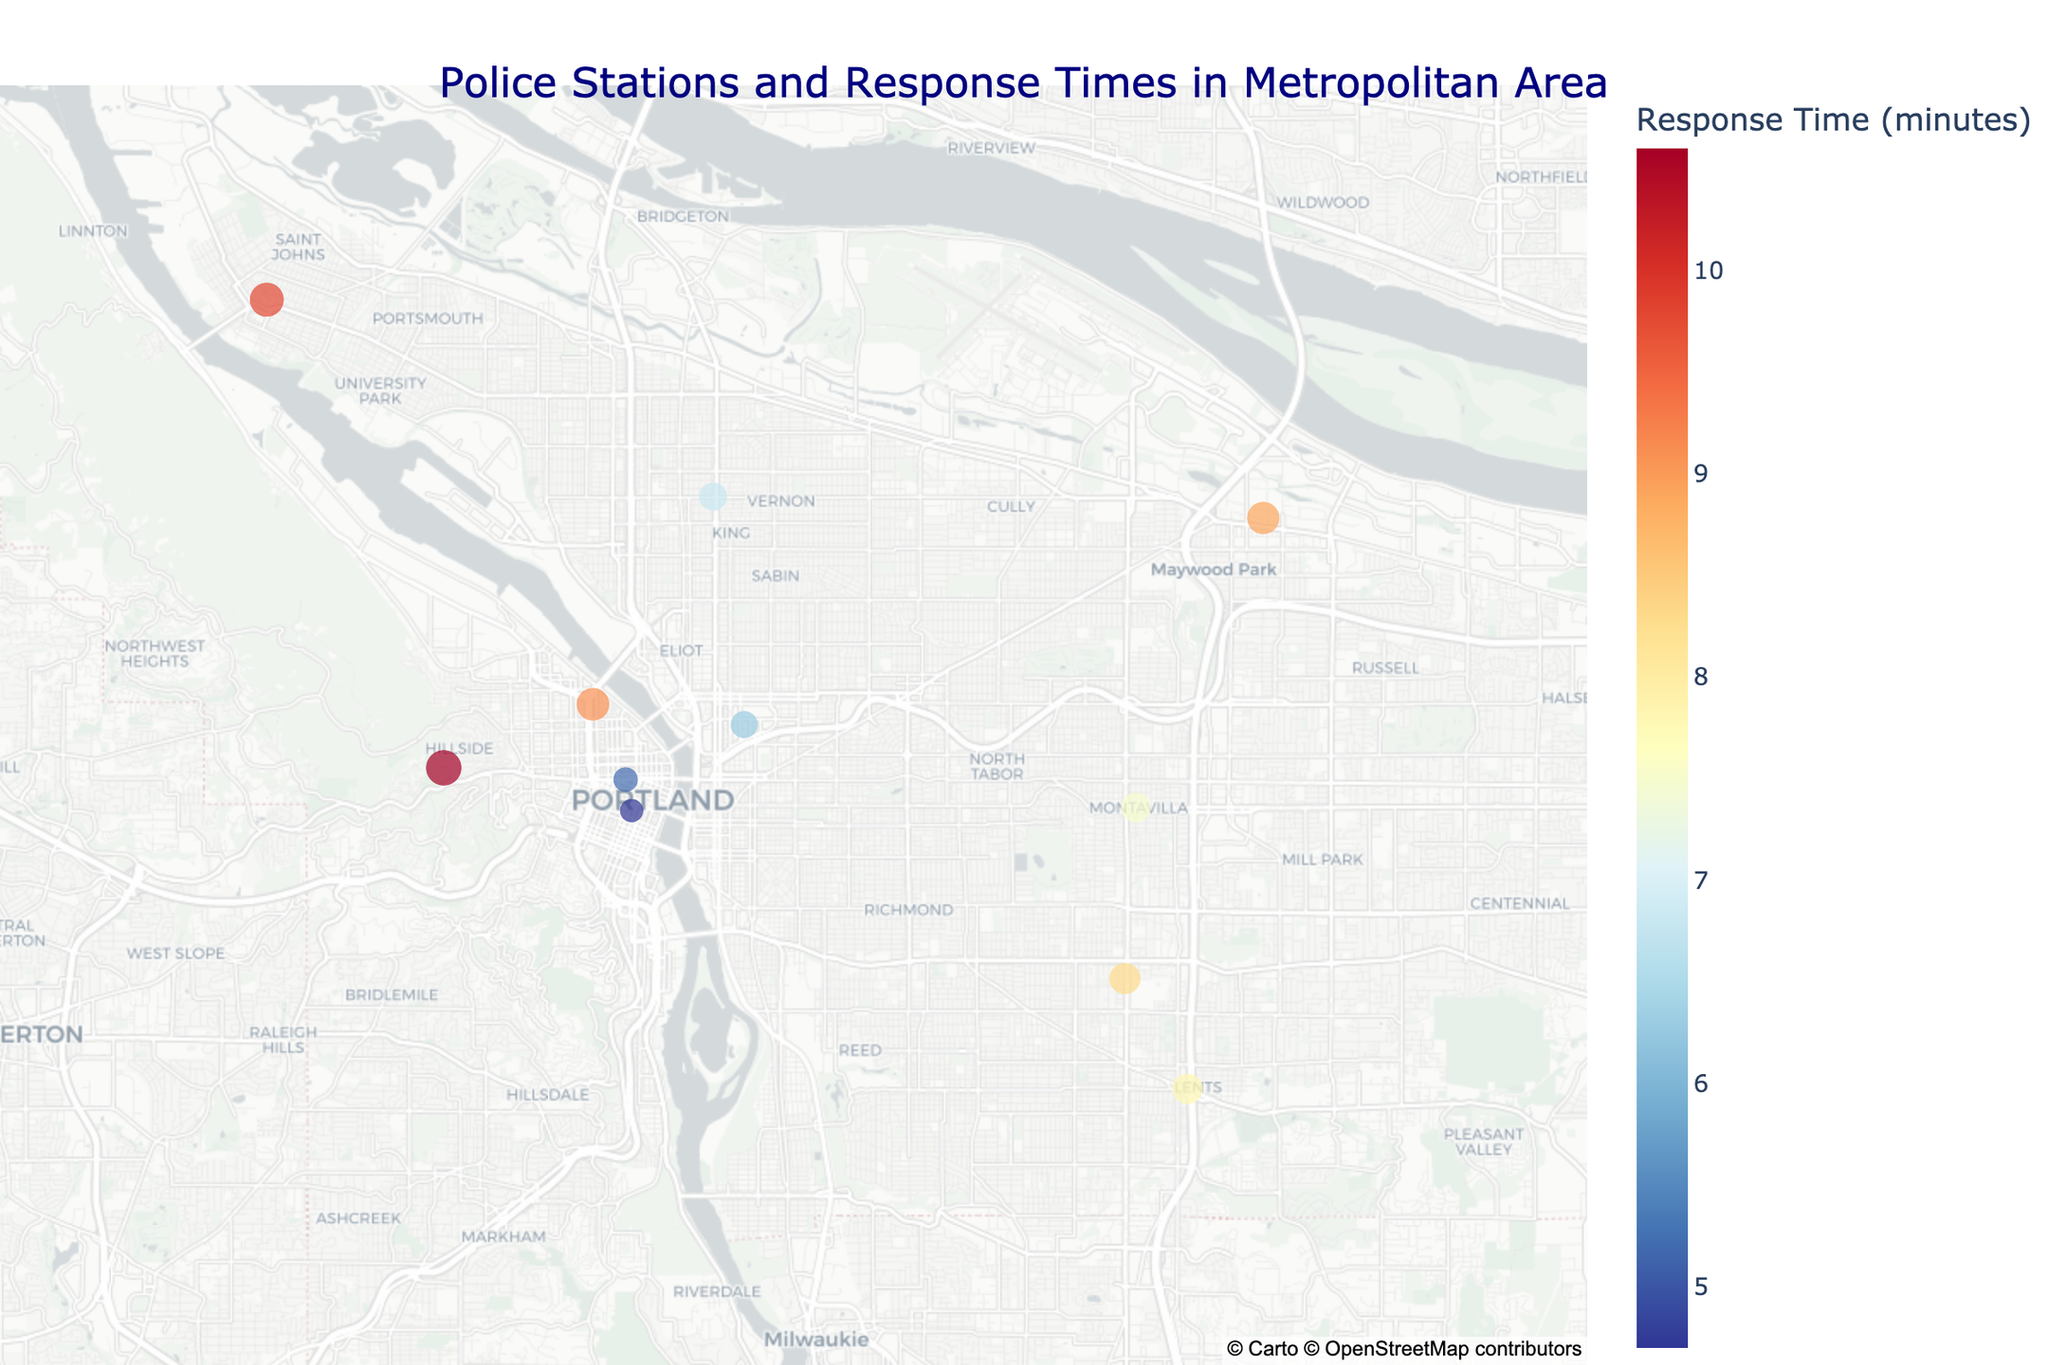What is the title of the map? The title is prominent at the top of the map and clearly indicates what the map is about.
Answer: Police Stations and Response Times in Metropolitan Area Which police station has the shortest response time? By looking at the color and size of the points, the smallest and darkest colored point represents the station with the shortest response time.
Answer: Downtown Substation Which precinct has the longest response time? The largest and lightest colored dot signifies the precinct with the longest response time on the map.
Answer: Training Division How many police stations are represented on the map? Counting each individual point on the map reveals the total number of police stations.
Answer: Eleven What is the response time range shown on the color bar of the map? The color bar indicates the lowest and highest response times by the colors it represents.
Answer: 4.7 to 10.6 minutes Is there a correlation between the size of the dots and response times? Larger dots correlate with higher response times, as the size of the points increases with longer response times.
Answer: Yes Compare the response times of the Central Precinct and North Precinct. Which one is quicker? By locating both precincts on the map and checking their hover data, we can compare response times directly.
Answer: Central Precinct What's the average response time for all the stations in the map? Sum all the response times and divide by the number of stations: (5.2 + 6.8 + 7.5 + 8.3 + 9.1 + 10.6 + 4.7 + 9.8 + 6.3 + 8.9 + 7.8) / 11 = 85 / 11 = 7.7 minutes.
Answer: 7.7 minutes Do any of the police stations have response times equal to or less than 5 minutes? Check the hover data for each station to identify any with response times ≤ 5 minutes.
Answer: Yes, Downtown Substation and Central Precinct Which substation has a higher response time: Parkrose Substation or Lents Substation? Compare the response times by examining the hover data of both substations on the map.
Answer: Parkrose Substation 